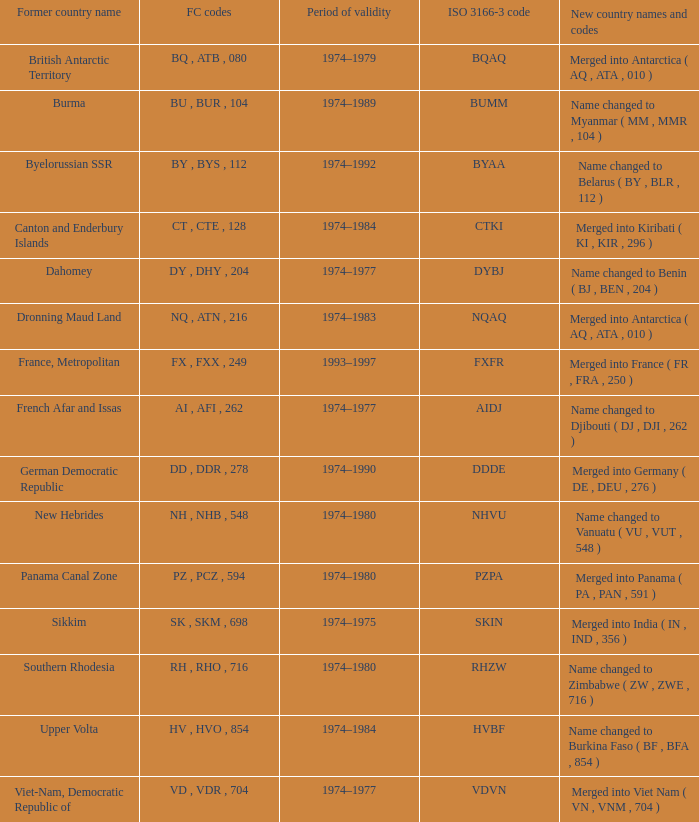Name the total number for period of validity for upper volta 1.0. 